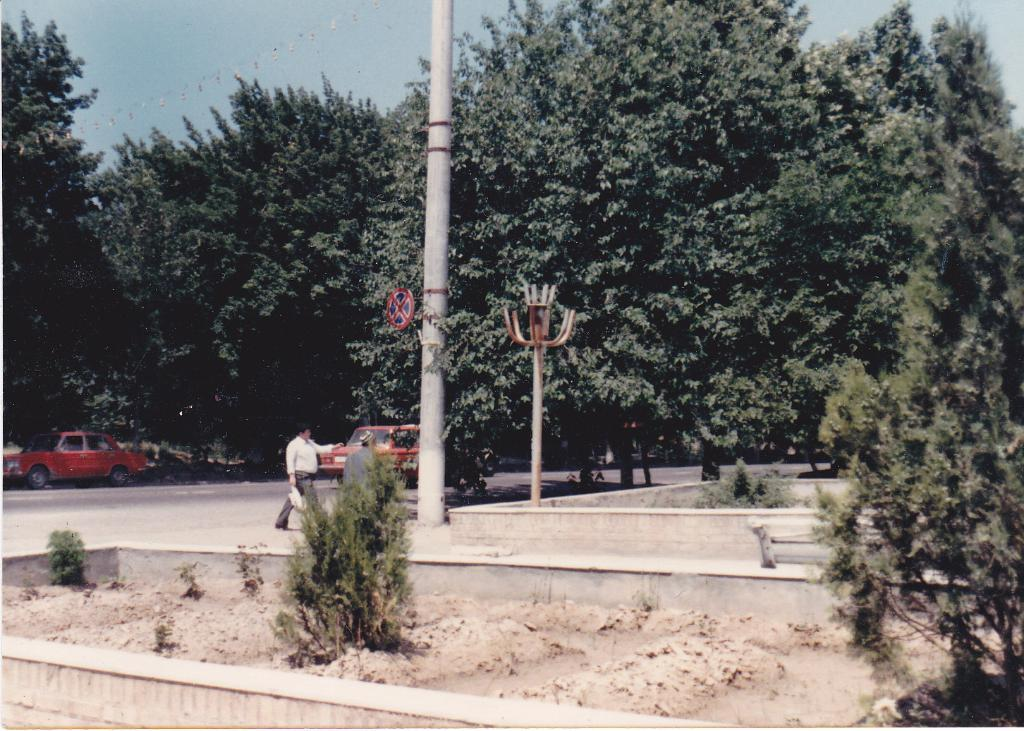What can be seen on the road in the image? There are cars on the road in the image. What type of vegetation is visible beside the road? There are trees beside the road in the image. What is the man in the image doing? The man is walking in the image. Where is the man walking in relation to other objects in the image? The man is walking beside a pole in the image. What type of cheese is hanging from the tree in the image? There is no cheese present in the image; it features cars on the road, trees beside the road, and a man walking beside a pole. What shape is the pear taking as it forms in the image? There is no pear present in the image, and therefore no formation process can be observed. 